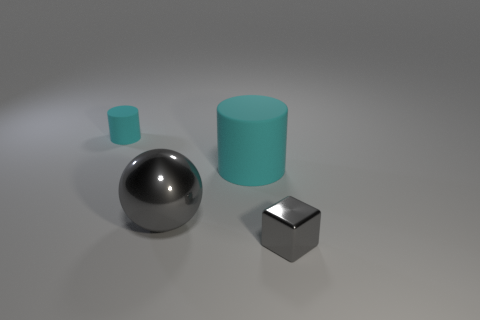What number of objects are big gray things or cyan rubber cylinders that are right of the tiny rubber cylinder?
Your response must be concise. 2. There is a gray sphere that is the same material as the block; what size is it?
Provide a succinct answer. Large. Are there more cyan objects that are on the right side of the big sphere than cyan spheres?
Ensure brevity in your answer.  Yes. What size is the thing that is right of the ball and behind the small block?
Provide a short and direct response. Large. There is a gray metal object that is behind the gray block; is its size the same as the small gray shiny thing?
Ensure brevity in your answer.  No. The thing that is right of the metal sphere and behind the cube is what color?
Provide a short and direct response. Cyan. What number of cyan rubber cylinders are right of the matte cylinder that is on the left side of the large gray shiny thing?
Provide a short and direct response. 1. Do the big cyan thing and the small cyan object have the same shape?
Ensure brevity in your answer.  Yes. Are there any other things that have the same color as the big sphere?
Give a very brief answer. Yes. There is a big cyan thing; is it the same shape as the small thing that is behind the big gray sphere?
Your response must be concise. Yes. 